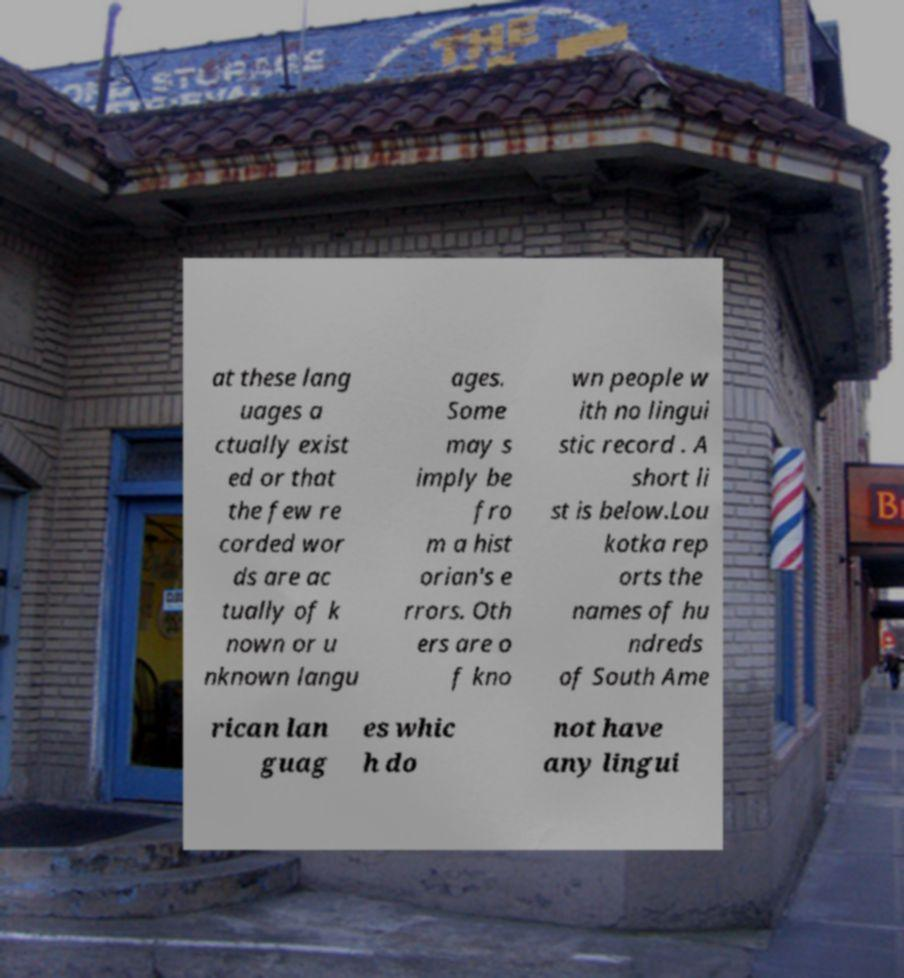Could you assist in decoding the text presented in this image and type it out clearly? at these lang uages a ctually exist ed or that the few re corded wor ds are ac tually of k nown or u nknown langu ages. Some may s imply be fro m a hist orian's e rrors. Oth ers are o f kno wn people w ith no lingui stic record . A short li st is below.Lou kotka rep orts the names of hu ndreds of South Ame rican lan guag es whic h do not have any lingui 